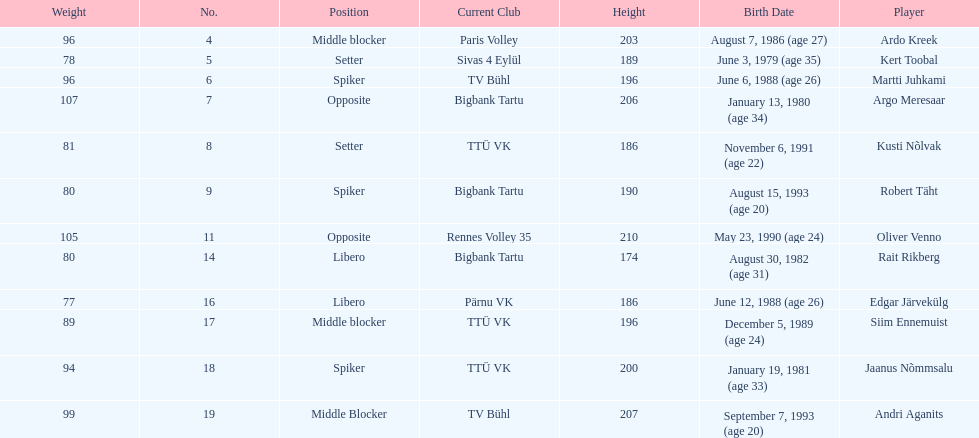How much taller in oliver venno than rait rikberg? 36. Give me the full table as a dictionary. {'header': ['Weight', 'No.', 'Position', 'Current Club', 'Height', 'Birth Date', 'Player'], 'rows': [['96', '4', 'Middle blocker', 'Paris Volley', '203', 'August 7, 1986 (age\xa027)', 'Ardo Kreek'], ['78', '5', 'Setter', 'Sivas 4 Eylül', '189', 'June 3, 1979 (age\xa035)', 'Kert Toobal'], ['96', '6', 'Spiker', 'TV Bühl', '196', 'June 6, 1988 (age\xa026)', 'Martti Juhkami'], ['107', '7', 'Opposite', 'Bigbank Tartu', '206', 'January 13, 1980 (age\xa034)', 'Argo Meresaar'], ['81', '8', 'Setter', 'TTÜ VK', '186', 'November 6, 1991 (age\xa022)', 'Kusti Nõlvak'], ['80', '9', 'Spiker', 'Bigbank Tartu', '190', 'August 15, 1993 (age\xa020)', 'Robert Täht'], ['105', '11', 'Opposite', 'Rennes Volley 35', '210', 'May 23, 1990 (age\xa024)', 'Oliver Venno'], ['80', '14', 'Libero', 'Bigbank Tartu', '174', 'August 30, 1982 (age\xa031)', 'Rait Rikberg'], ['77', '16', 'Libero', 'Pärnu VK', '186', 'June 12, 1988 (age\xa026)', 'Edgar Järvekülg'], ['89', '17', 'Middle blocker', 'TTÜ VK', '196', 'December 5, 1989 (age\xa024)', 'Siim Ennemuist'], ['94', '18', 'Spiker', 'TTÜ VK', '200', 'January 19, 1981 (age\xa033)', 'Jaanus Nõmmsalu'], ['99', '19', 'Middle Blocker', 'TV Bühl', '207', 'September 7, 1993 (age\xa020)', 'Andri Aganits']]} 